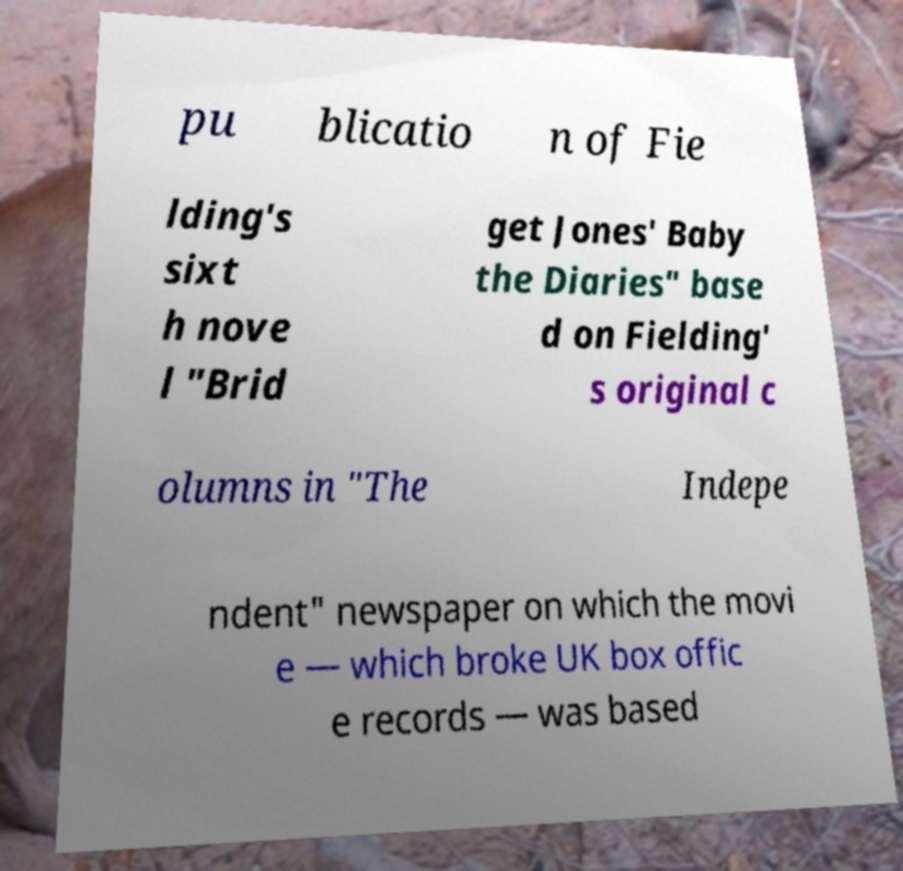I need the written content from this picture converted into text. Can you do that? pu blicatio n of Fie lding's sixt h nove l "Brid get Jones' Baby the Diaries" base d on Fielding' s original c olumns in "The Indepe ndent" newspaper on which the movi e — which broke UK box offic e records — was based 